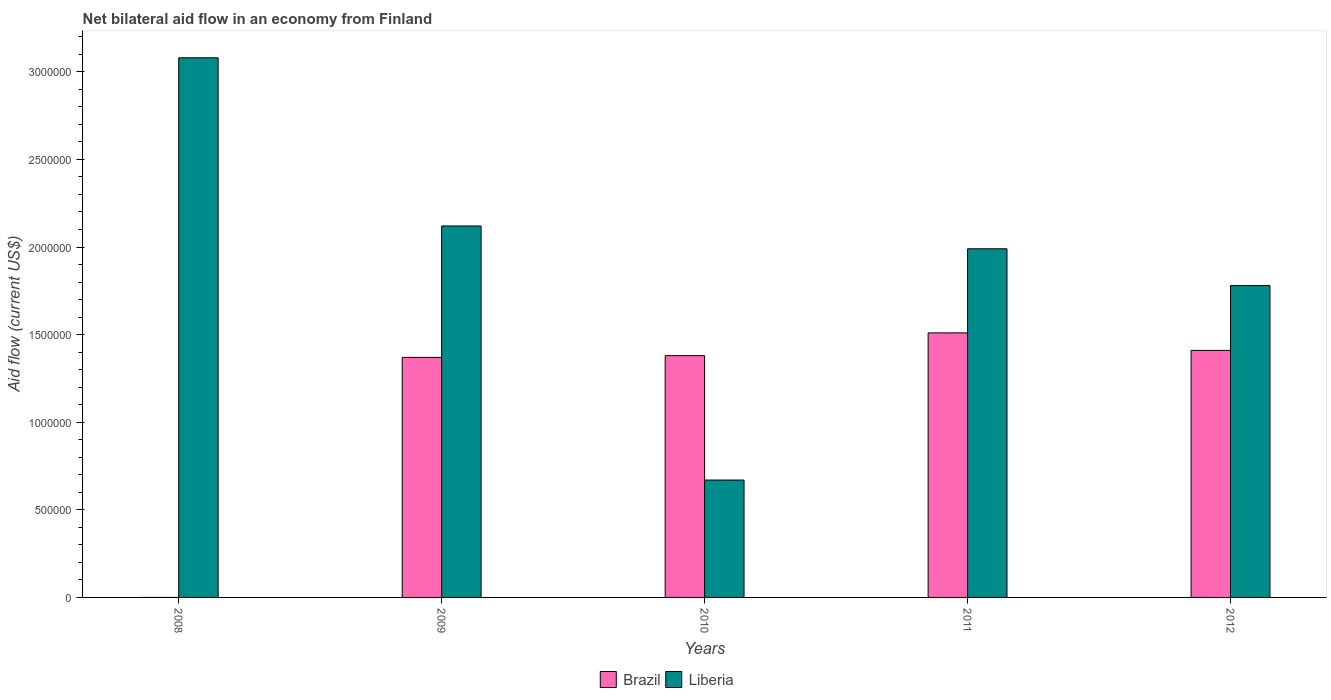Are the number of bars on each tick of the X-axis equal?
Provide a succinct answer. No. How many bars are there on the 1st tick from the left?
Provide a succinct answer. 1. What is the net bilateral aid flow in Brazil in 2009?
Offer a terse response. 1.37e+06. Across all years, what is the maximum net bilateral aid flow in Brazil?
Offer a terse response. 1.51e+06. What is the total net bilateral aid flow in Brazil in the graph?
Give a very brief answer. 5.67e+06. What is the difference between the net bilateral aid flow in Brazil in 2010 and that in 2012?
Ensure brevity in your answer.  -3.00e+04. What is the difference between the net bilateral aid flow in Liberia in 2011 and the net bilateral aid flow in Brazil in 2012?
Ensure brevity in your answer.  5.80e+05. What is the average net bilateral aid flow in Liberia per year?
Keep it short and to the point. 1.93e+06. In the year 2010, what is the difference between the net bilateral aid flow in Brazil and net bilateral aid flow in Liberia?
Your response must be concise. 7.10e+05. In how many years, is the net bilateral aid flow in Brazil greater than 2000000 US$?
Provide a succinct answer. 0. What is the ratio of the net bilateral aid flow in Liberia in 2010 to that in 2012?
Give a very brief answer. 0.38. Is the net bilateral aid flow in Liberia in 2009 less than that in 2012?
Your response must be concise. No. Is the difference between the net bilateral aid flow in Brazil in 2009 and 2011 greater than the difference between the net bilateral aid flow in Liberia in 2009 and 2011?
Your answer should be very brief. No. What is the difference between the highest and the second highest net bilateral aid flow in Liberia?
Ensure brevity in your answer.  9.60e+05. What is the difference between the highest and the lowest net bilateral aid flow in Liberia?
Keep it short and to the point. 2.41e+06. In how many years, is the net bilateral aid flow in Liberia greater than the average net bilateral aid flow in Liberia taken over all years?
Provide a succinct answer. 3. How many bars are there?
Offer a terse response. 9. Are all the bars in the graph horizontal?
Ensure brevity in your answer.  No. Does the graph contain any zero values?
Your response must be concise. Yes. How many legend labels are there?
Offer a terse response. 2. What is the title of the graph?
Provide a short and direct response. Net bilateral aid flow in an economy from Finland. Does "South Asia" appear as one of the legend labels in the graph?
Provide a short and direct response. No. What is the label or title of the X-axis?
Your answer should be very brief. Years. What is the Aid flow (current US$) in Liberia in 2008?
Provide a short and direct response. 3.08e+06. What is the Aid flow (current US$) of Brazil in 2009?
Offer a terse response. 1.37e+06. What is the Aid flow (current US$) in Liberia in 2009?
Your response must be concise. 2.12e+06. What is the Aid flow (current US$) in Brazil in 2010?
Provide a short and direct response. 1.38e+06. What is the Aid flow (current US$) in Liberia in 2010?
Offer a terse response. 6.70e+05. What is the Aid flow (current US$) in Brazil in 2011?
Ensure brevity in your answer.  1.51e+06. What is the Aid flow (current US$) in Liberia in 2011?
Ensure brevity in your answer.  1.99e+06. What is the Aid flow (current US$) of Brazil in 2012?
Your answer should be compact. 1.41e+06. What is the Aid flow (current US$) of Liberia in 2012?
Give a very brief answer. 1.78e+06. Across all years, what is the maximum Aid flow (current US$) in Brazil?
Your response must be concise. 1.51e+06. Across all years, what is the maximum Aid flow (current US$) of Liberia?
Your response must be concise. 3.08e+06. Across all years, what is the minimum Aid flow (current US$) in Brazil?
Provide a short and direct response. 0. Across all years, what is the minimum Aid flow (current US$) in Liberia?
Provide a short and direct response. 6.70e+05. What is the total Aid flow (current US$) in Brazil in the graph?
Offer a terse response. 5.67e+06. What is the total Aid flow (current US$) of Liberia in the graph?
Offer a terse response. 9.64e+06. What is the difference between the Aid flow (current US$) in Liberia in 2008 and that in 2009?
Offer a very short reply. 9.60e+05. What is the difference between the Aid flow (current US$) of Liberia in 2008 and that in 2010?
Keep it short and to the point. 2.41e+06. What is the difference between the Aid flow (current US$) of Liberia in 2008 and that in 2011?
Make the answer very short. 1.09e+06. What is the difference between the Aid flow (current US$) in Liberia in 2008 and that in 2012?
Your answer should be very brief. 1.30e+06. What is the difference between the Aid flow (current US$) of Brazil in 2009 and that in 2010?
Your answer should be very brief. -10000. What is the difference between the Aid flow (current US$) in Liberia in 2009 and that in 2010?
Ensure brevity in your answer.  1.45e+06. What is the difference between the Aid flow (current US$) of Brazil in 2009 and that in 2011?
Your answer should be very brief. -1.40e+05. What is the difference between the Aid flow (current US$) in Liberia in 2009 and that in 2011?
Ensure brevity in your answer.  1.30e+05. What is the difference between the Aid flow (current US$) of Brazil in 2009 and that in 2012?
Make the answer very short. -4.00e+04. What is the difference between the Aid flow (current US$) in Liberia in 2009 and that in 2012?
Offer a very short reply. 3.40e+05. What is the difference between the Aid flow (current US$) of Brazil in 2010 and that in 2011?
Your answer should be compact. -1.30e+05. What is the difference between the Aid flow (current US$) in Liberia in 2010 and that in 2011?
Provide a short and direct response. -1.32e+06. What is the difference between the Aid flow (current US$) in Liberia in 2010 and that in 2012?
Your response must be concise. -1.11e+06. What is the difference between the Aid flow (current US$) of Brazil in 2009 and the Aid flow (current US$) of Liberia in 2011?
Provide a short and direct response. -6.20e+05. What is the difference between the Aid flow (current US$) in Brazil in 2009 and the Aid flow (current US$) in Liberia in 2012?
Provide a short and direct response. -4.10e+05. What is the difference between the Aid flow (current US$) of Brazil in 2010 and the Aid flow (current US$) of Liberia in 2011?
Provide a short and direct response. -6.10e+05. What is the difference between the Aid flow (current US$) in Brazil in 2010 and the Aid flow (current US$) in Liberia in 2012?
Give a very brief answer. -4.00e+05. What is the difference between the Aid flow (current US$) of Brazil in 2011 and the Aid flow (current US$) of Liberia in 2012?
Provide a short and direct response. -2.70e+05. What is the average Aid flow (current US$) of Brazil per year?
Provide a short and direct response. 1.13e+06. What is the average Aid flow (current US$) in Liberia per year?
Ensure brevity in your answer.  1.93e+06. In the year 2009, what is the difference between the Aid flow (current US$) in Brazil and Aid flow (current US$) in Liberia?
Provide a short and direct response. -7.50e+05. In the year 2010, what is the difference between the Aid flow (current US$) in Brazil and Aid flow (current US$) in Liberia?
Offer a terse response. 7.10e+05. In the year 2011, what is the difference between the Aid flow (current US$) in Brazil and Aid flow (current US$) in Liberia?
Provide a succinct answer. -4.80e+05. In the year 2012, what is the difference between the Aid flow (current US$) in Brazil and Aid flow (current US$) in Liberia?
Give a very brief answer. -3.70e+05. What is the ratio of the Aid flow (current US$) of Liberia in 2008 to that in 2009?
Make the answer very short. 1.45. What is the ratio of the Aid flow (current US$) in Liberia in 2008 to that in 2010?
Provide a succinct answer. 4.6. What is the ratio of the Aid flow (current US$) of Liberia in 2008 to that in 2011?
Make the answer very short. 1.55. What is the ratio of the Aid flow (current US$) in Liberia in 2008 to that in 2012?
Ensure brevity in your answer.  1.73. What is the ratio of the Aid flow (current US$) in Liberia in 2009 to that in 2010?
Give a very brief answer. 3.16. What is the ratio of the Aid flow (current US$) in Brazil in 2009 to that in 2011?
Your response must be concise. 0.91. What is the ratio of the Aid flow (current US$) in Liberia in 2009 to that in 2011?
Make the answer very short. 1.07. What is the ratio of the Aid flow (current US$) of Brazil in 2009 to that in 2012?
Your response must be concise. 0.97. What is the ratio of the Aid flow (current US$) in Liberia in 2009 to that in 2012?
Keep it short and to the point. 1.19. What is the ratio of the Aid flow (current US$) of Brazil in 2010 to that in 2011?
Give a very brief answer. 0.91. What is the ratio of the Aid flow (current US$) of Liberia in 2010 to that in 2011?
Keep it short and to the point. 0.34. What is the ratio of the Aid flow (current US$) in Brazil in 2010 to that in 2012?
Ensure brevity in your answer.  0.98. What is the ratio of the Aid flow (current US$) in Liberia in 2010 to that in 2012?
Make the answer very short. 0.38. What is the ratio of the Aid flow (current US$) of Brazil in 2011 to that in 2012?
Your response must be concise. 1.07. What is the ratio of the Aid flow (current US$) in Liberia in 2011 to that in 2012?
Keep it short and to the point. 1.12. What is the difference between the highest and the second highest Aid flow (current US$) of Liberia?
Make the answer very short. 9.60e+05. What is the difference between the highest and the lowest Aid flow (current US$) of Brazil?
Give a very brief answer. 1.51e+06. What is the difference between the highest and the lowest Aid flow (current US$) in Liberia?
Ensure brevity in your answer.  2.41e+06. 